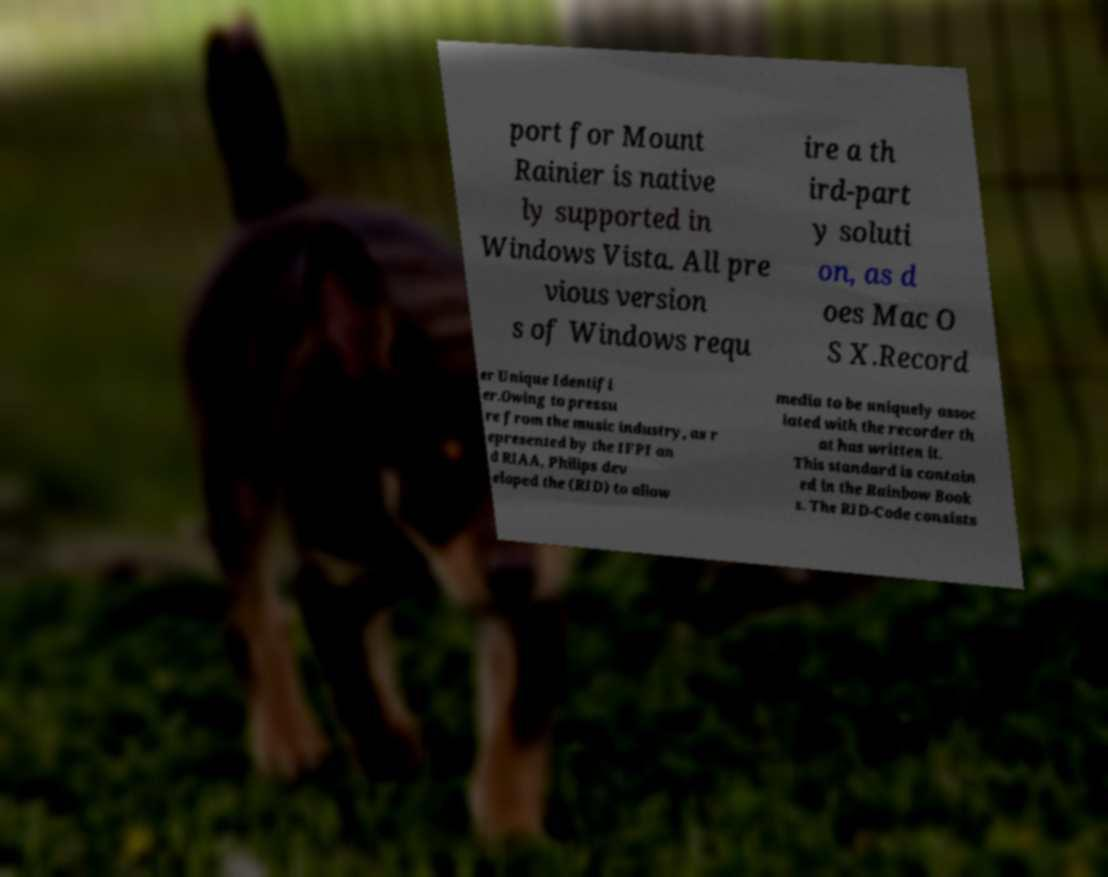Please identify and transcribe the text found in this image. port for Mount Rainier is native ly supported in Windows Vista. All pre vious version s of Windows requ ire a th ird-part y soluti on, as d oes Mac O S X.Record er Unique Identifi er.Owing to pressu re from the music industry, as r epresented by the IFPI an d RIAA, Philips dev eloped the (RID) to allow media to be uniquely assoc iated with the recorder th at has written it. This standard is contain ed in the Rainbow Book s. The RID-Code consists 